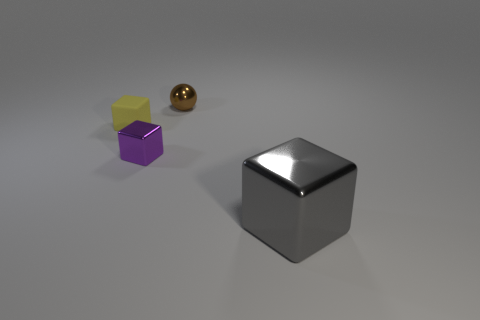What color is the shiny cube that is left of the block in front of the metallic block that is left of the gray metal thing?
Make the answer very short. Purple. Is there any other thing that has the same shape as the small brown metal object?
Give a very brief answer. No. Are there more brown metal objects than blue objects?
Your response must be concise. Yes. How many tiny metal things are in front of the matte block and behind the purple cube?
Your answer should be compact. 0. How many large gray blocks are to the left of the small cube left of the purple metal block?
Offer a terse response. 0. Is the size of the shiny thing left of the metal sphere the same as the shiny object that is right of the small brown thing?
Provide a succinct answer. No. How many yellow things are there?
Give a very brief answer. 1. What number of tiny blocks have the same material as the small brown sphere?
Give a very brief answer. 1. Is the number of gray metal objects that are to the left of the purple shiny thing the same as the number of gray metallic cylinders?
Provide a succinct answer. Yes. Does the brown ball have the same size as the block behind the small purple metallic object?
Offer a terse response. Yes. 